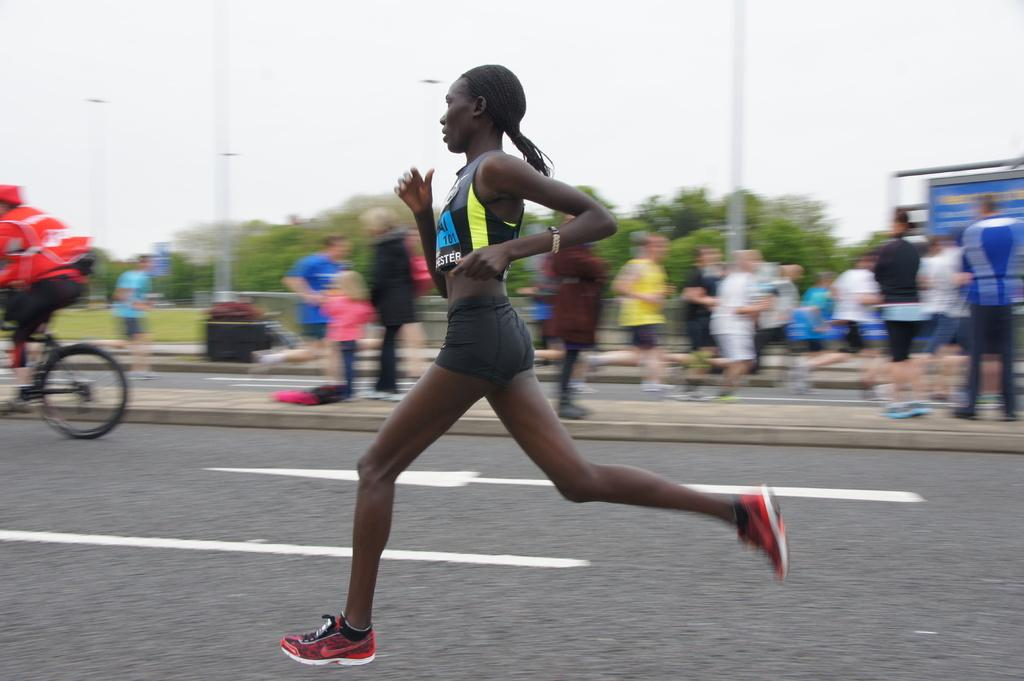What can be seen in the image? There are people, trees, and a banner in the image. What is the man wearing in the image? The man is wearing a red jacket in the image. What is the man doing in the image? The man is riding a bicycle in the image. Where is the man located in the image? The man is on the left side of the image. What is visible in the background of the image? The sky is visible in the image. Can you tell me how many holes are in the man's hair in the image? There is no mention of the man's hair in the image, and therefore no holes can be observed. What type of cover is on the bicycle in the image? There is no mention of a cover on the bicycle in the image. 